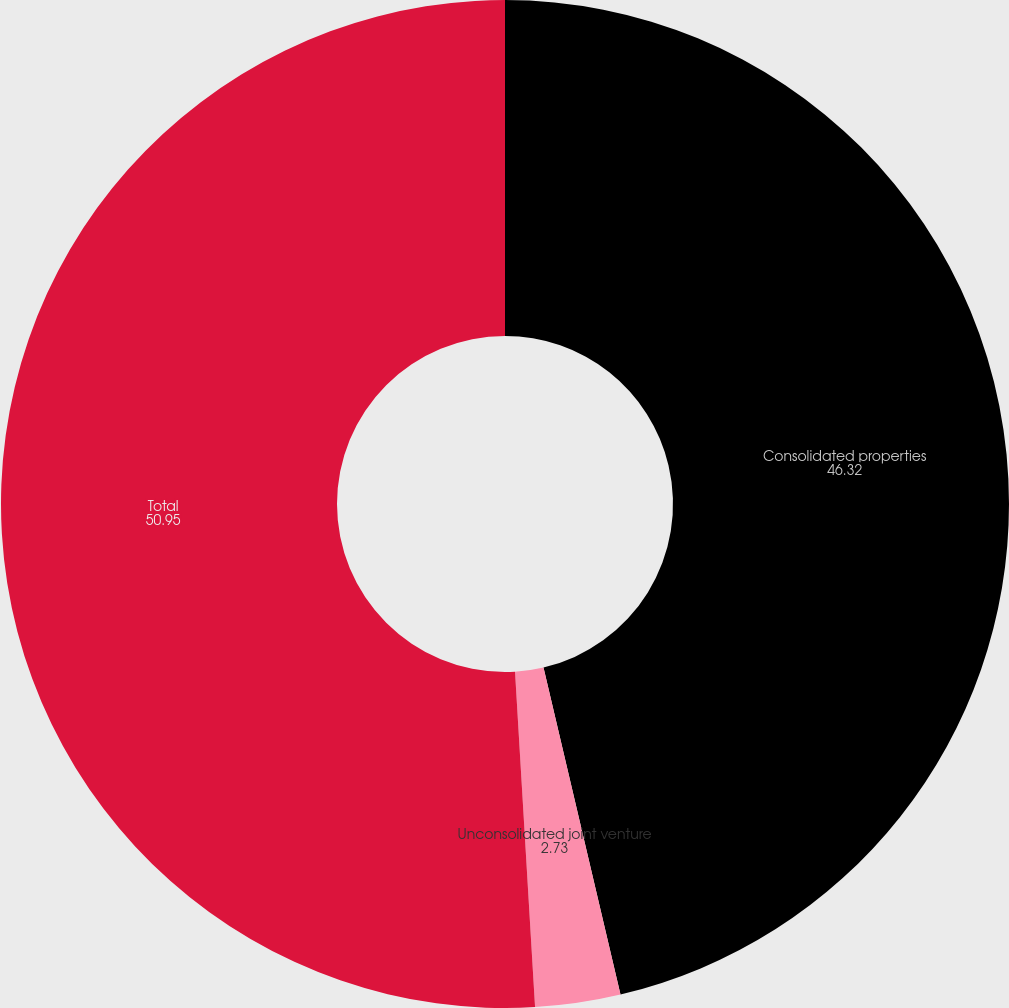<chart> <loc_0><loc_0><loc_500><loc_500><pie_chart><fcel>Consolidated properties<fcel>Unconsolidated joint venture<fcel>Total<nl><fcel>46.32%<fcel>2.73%<fcel>50.95%<nl></chart> 